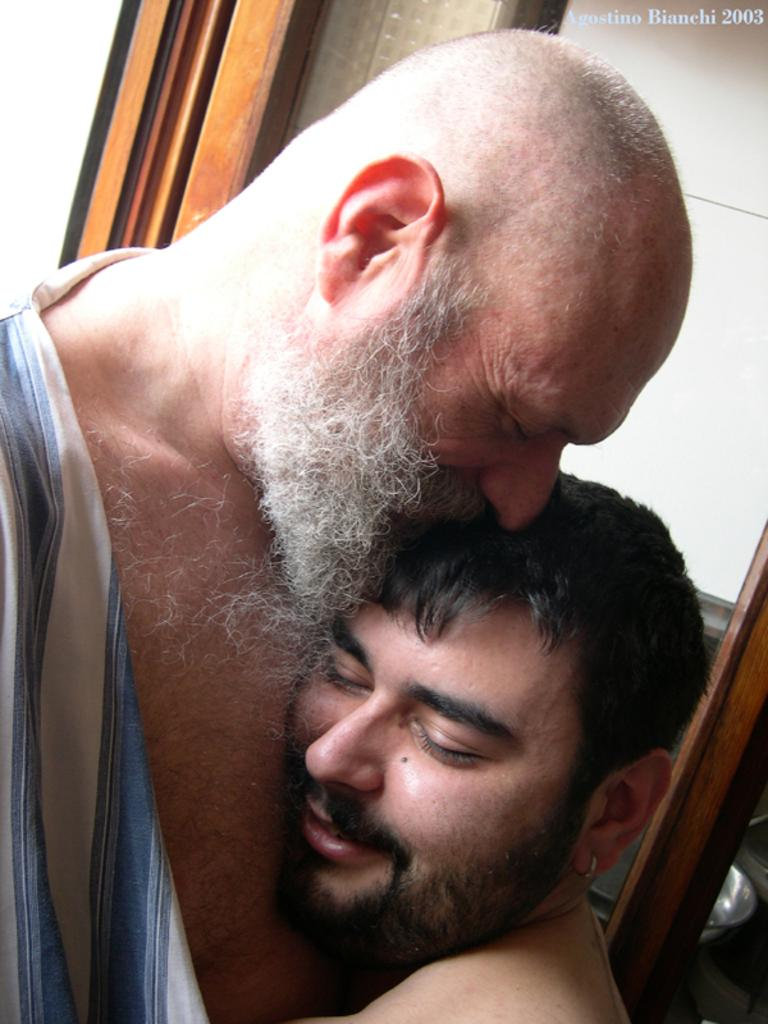How many people are present in the image? There are two men in the image. Can you describe any specific features or characteristics of the image? Yes, there is a watermark in the top right-hand side of the image. How many frogs can be seen in the image? There are no frogs present in the image. What type of glove is being worn by one of the men in the image? There is no information about gloves or any specific clothing worn by the men in the image. 